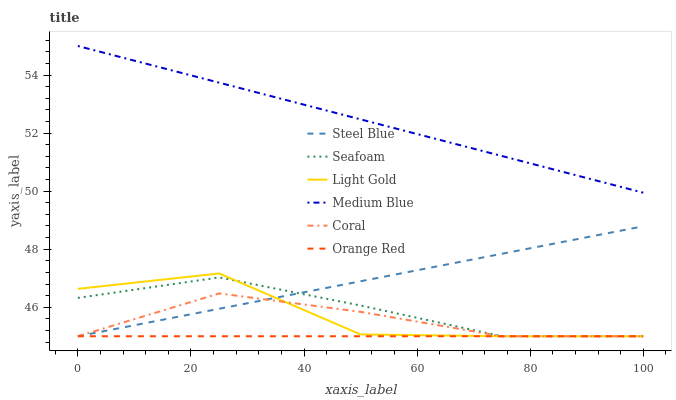Does Steel Blue have the minimum area under the curve?
Answer yes or no. No. Does Steel Blue have the maximum area under the curve?
Answer yes or no. No. Is Medium Blue the smoothest?
Answer yes or no. No. Is Medium Blue the roughest?
Answer yes or no. No. Does Medium Blue have the lowest value?
Answer yes or no. No. Does Steel Blue have the highest value?
Answer yes or no. No. Is Steel Blue less than Medium Blue?
Answer yes or no. Yes. Is Medium Blue greater than Steel Blue?
Answer yes or no. Yes. Does Steel Blue intersect Medium Blue?
Answer yes or no. No. 